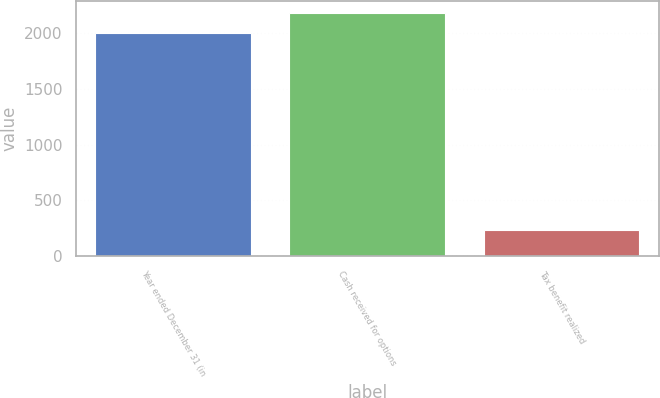Convert chart to OTSL. <chart><loc_0><loc_0><loc_500><loc_500><bar_chart><fcel>Year ended December 31 (in<fcel>Cash received for options<fcel>Tax benefit realized<nl><fcel>2007<fcel>2185.5<fcel>238<nl></chart> 